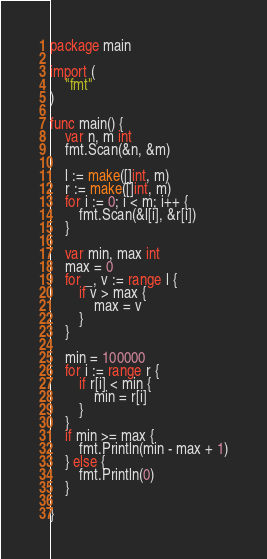<code> <loc_0><loc_0><loc_500><loc_500><_Go_>package main

import (
	"fmt"
)

func main() {
	var n, m int
	fmt.Scan(&n, &m)

	l := make([]int, m)
	r := make([]int, m)
	for i := 0; i < m; i++ {
		fmt.Scan(&l[i], &r[i])
	}

	var min, max int
	max = 0
	for _, v := range l {
		if v > max {
			max = v
		}
	}

	min = 100000
	for i := range r {
		if r[i] < min {
			min = r[i]
		}
	}
	if min >= max {
		fmt.Println(min - max + 1)
	} else {
		fmt.Println(0)
	}

}
</code> 